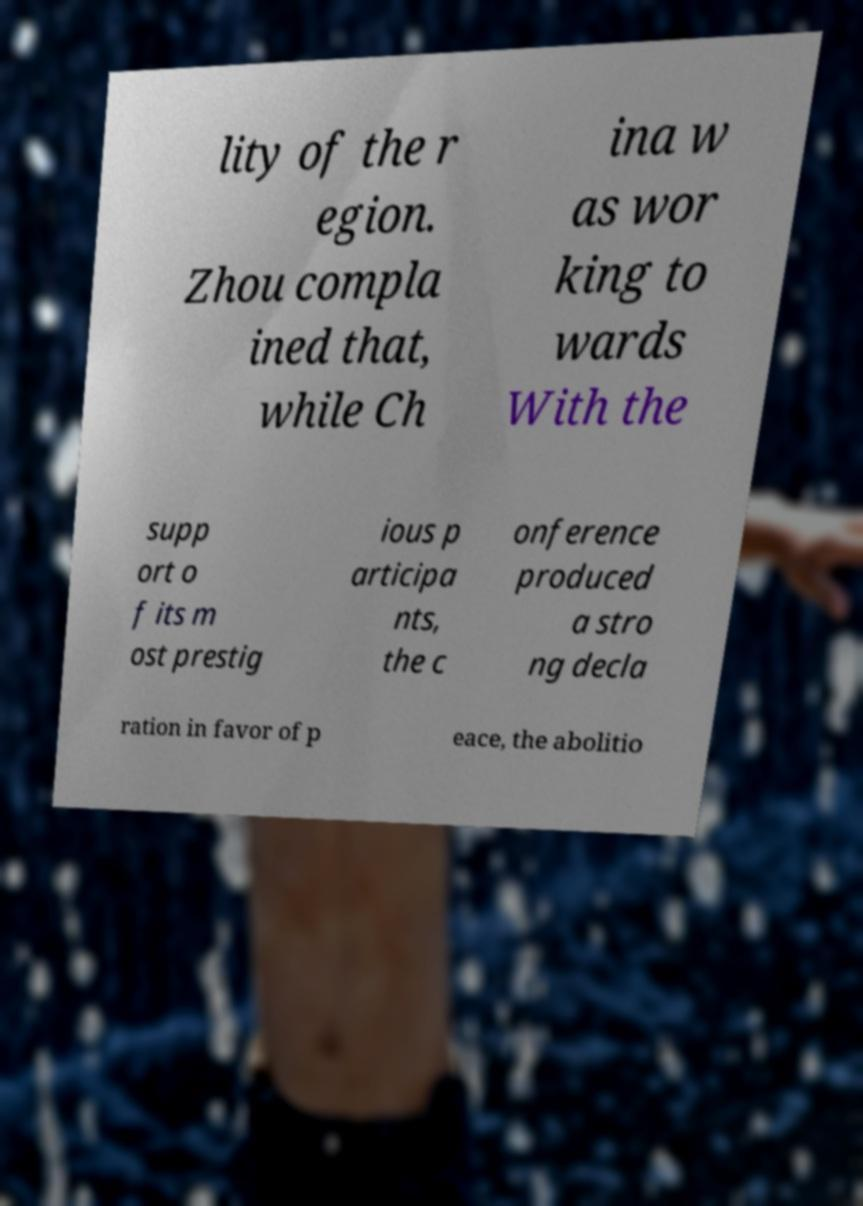Please read and relay the text visible in this image. What does it say? lity of the r egion. Zhou compla ined that, while Ch ina w as wor king to wards With the supp ort o f its m ost prestig ious p articipa nts, the c onference produced a stro ng decla ration in favor of p eace, the abolitio 